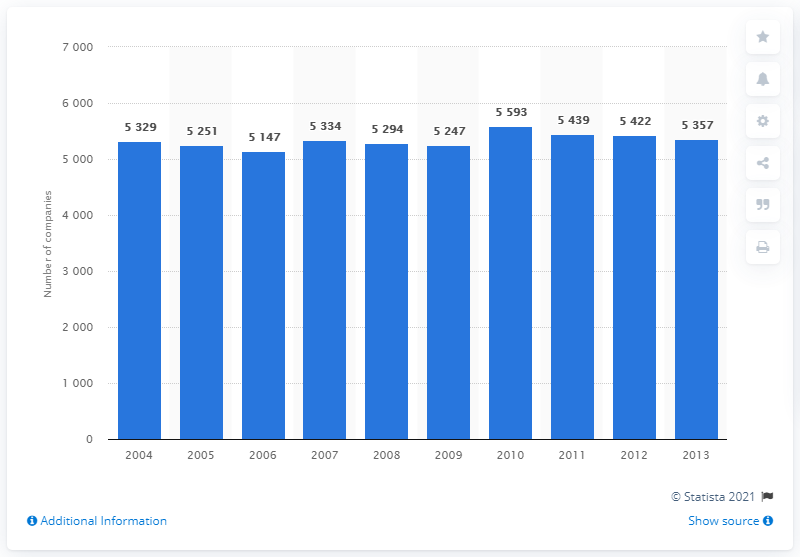Identify some key points in this picture. As of the end of 2013, a total of 5,357 companies were active in the insurance sector. The largest number of companies operating on the European market was reported in 2010. In 2010, the number of companies operating on the European market was the largest with 5,593 companies. 